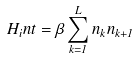<formula> <loc_0><loc_0><loc_500><loc_500>H _ { i } n t = \beta \sum _ { k = 1 } ^ { L } n _ { k } n _ { k + 1 }</formula> 